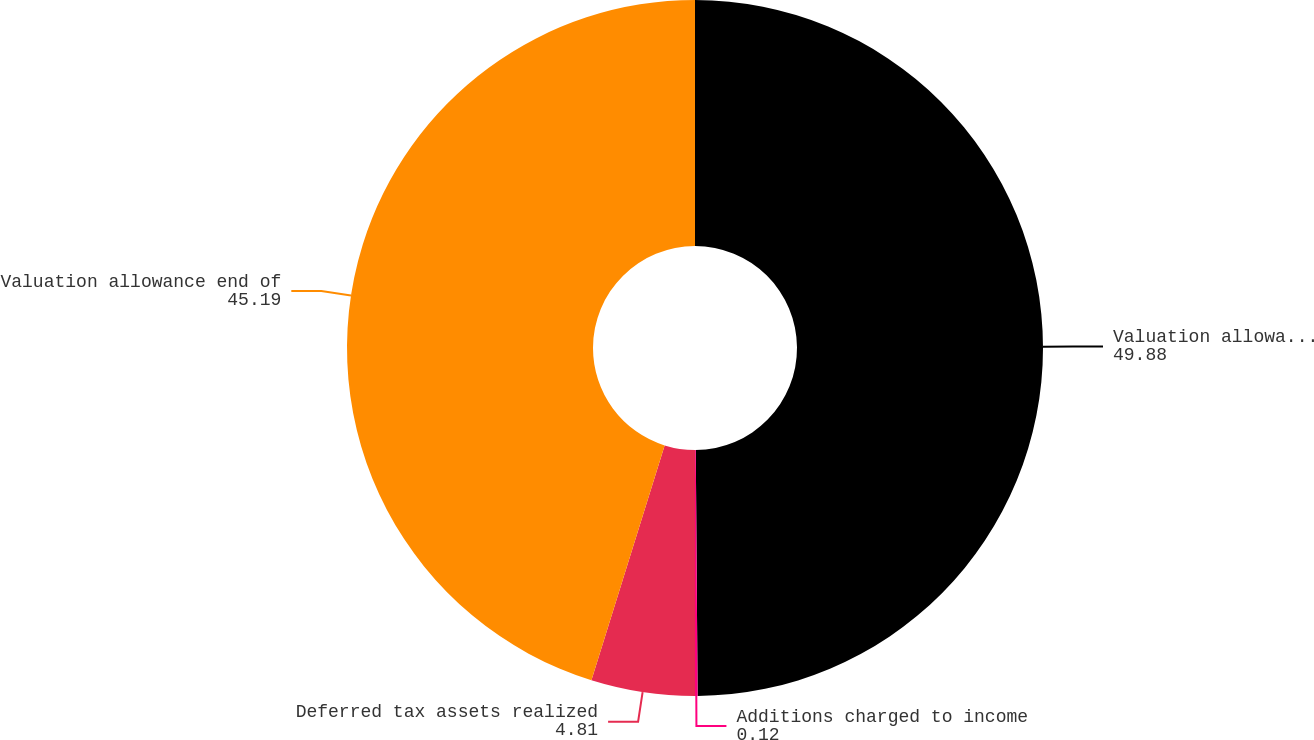Convert chart. <chart><loc_0><loc_0><loc_500><loc_500><pie_chart><fcel>Valuation allowance beginning<fcel>Additions charged to income<fcel>Deferred tax assets realized<fcel>Valuation allowance end of<nl><fcel>49.88%<fcel>0.12%<fcel>4.81%<fcel>45.19%<nl></chart> 